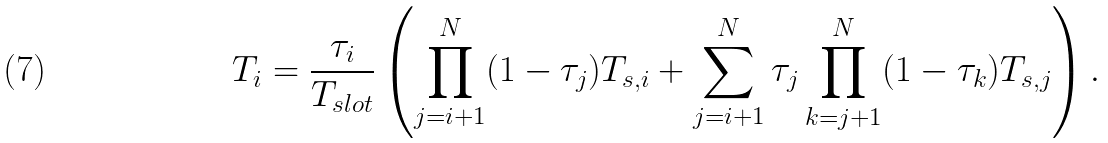Convert formula to latex. <formula><loc_0><loc_0><loc_500><loc_500>T _ { i } = \frac { \tau _ { i } } { T _ { s l o t } } \left ( \prod _ { j = i + 1 } ^ { N } ( 1 - \tau _ { j } ) T _ { s , i } + \sum _ { j = i + 1 } ^ { N } \tau _ { j } \prod _ { k = j + 1 } ^ { N } ( 1 - \tau _ { k } ) T _ { s , j } \right ) .</formula> 